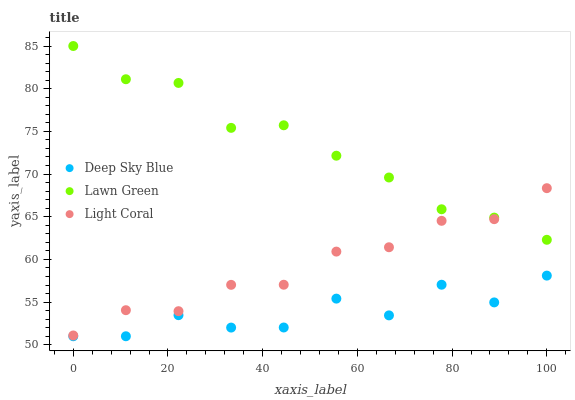Does Deep Sky Blue have the minimum area under the curve?
Answer yes or no. Yes. Does Lawn Green have the maximum area under the curve?
Answer yes or no. Yes. Does Lawn Green have the minimum area under the curve?
Answer yes or no. No. Does Deep Sky Blue have the maximum area under the curve?
Answer yes or no. No. Is Lawn Green the smoothest?
Answer yes or no. Yes. Is Deep Sky Blue the roughest?
Answer yes or no. Yes. Is Deep Sky Blue the smoothest?
Answer yes or no. No. Is Lawn Green the roughest?
Answer yes or no. No. Does Deep Sky Blue have the lowest value?
Answer yes or no. Yes. Does Lawn Green have the lowest value?
Answer yes or no. No. Does Lawn Green have the highest value?
Answer yes or no. Yes. Does Deep Sky Blue have the highest value?
Answer yes or no. No. Is Deep Sky Blue less than Lawn Green?
Answer yes or no. Yes. Is Light Coral greater than Deep Sky Blue?
Answer yes or no. Yes. Does Light Coral intersect Lawn Green?
Answer yes or no. Yes. Is Light Coral less than Lawn Green?
Answer yes or no. No. Is Light Coral greater than Lawn Green?
Answer yes or no. No. Does Deep Sky Blue intersect Lawn Green?
Answer yes or no. No. 